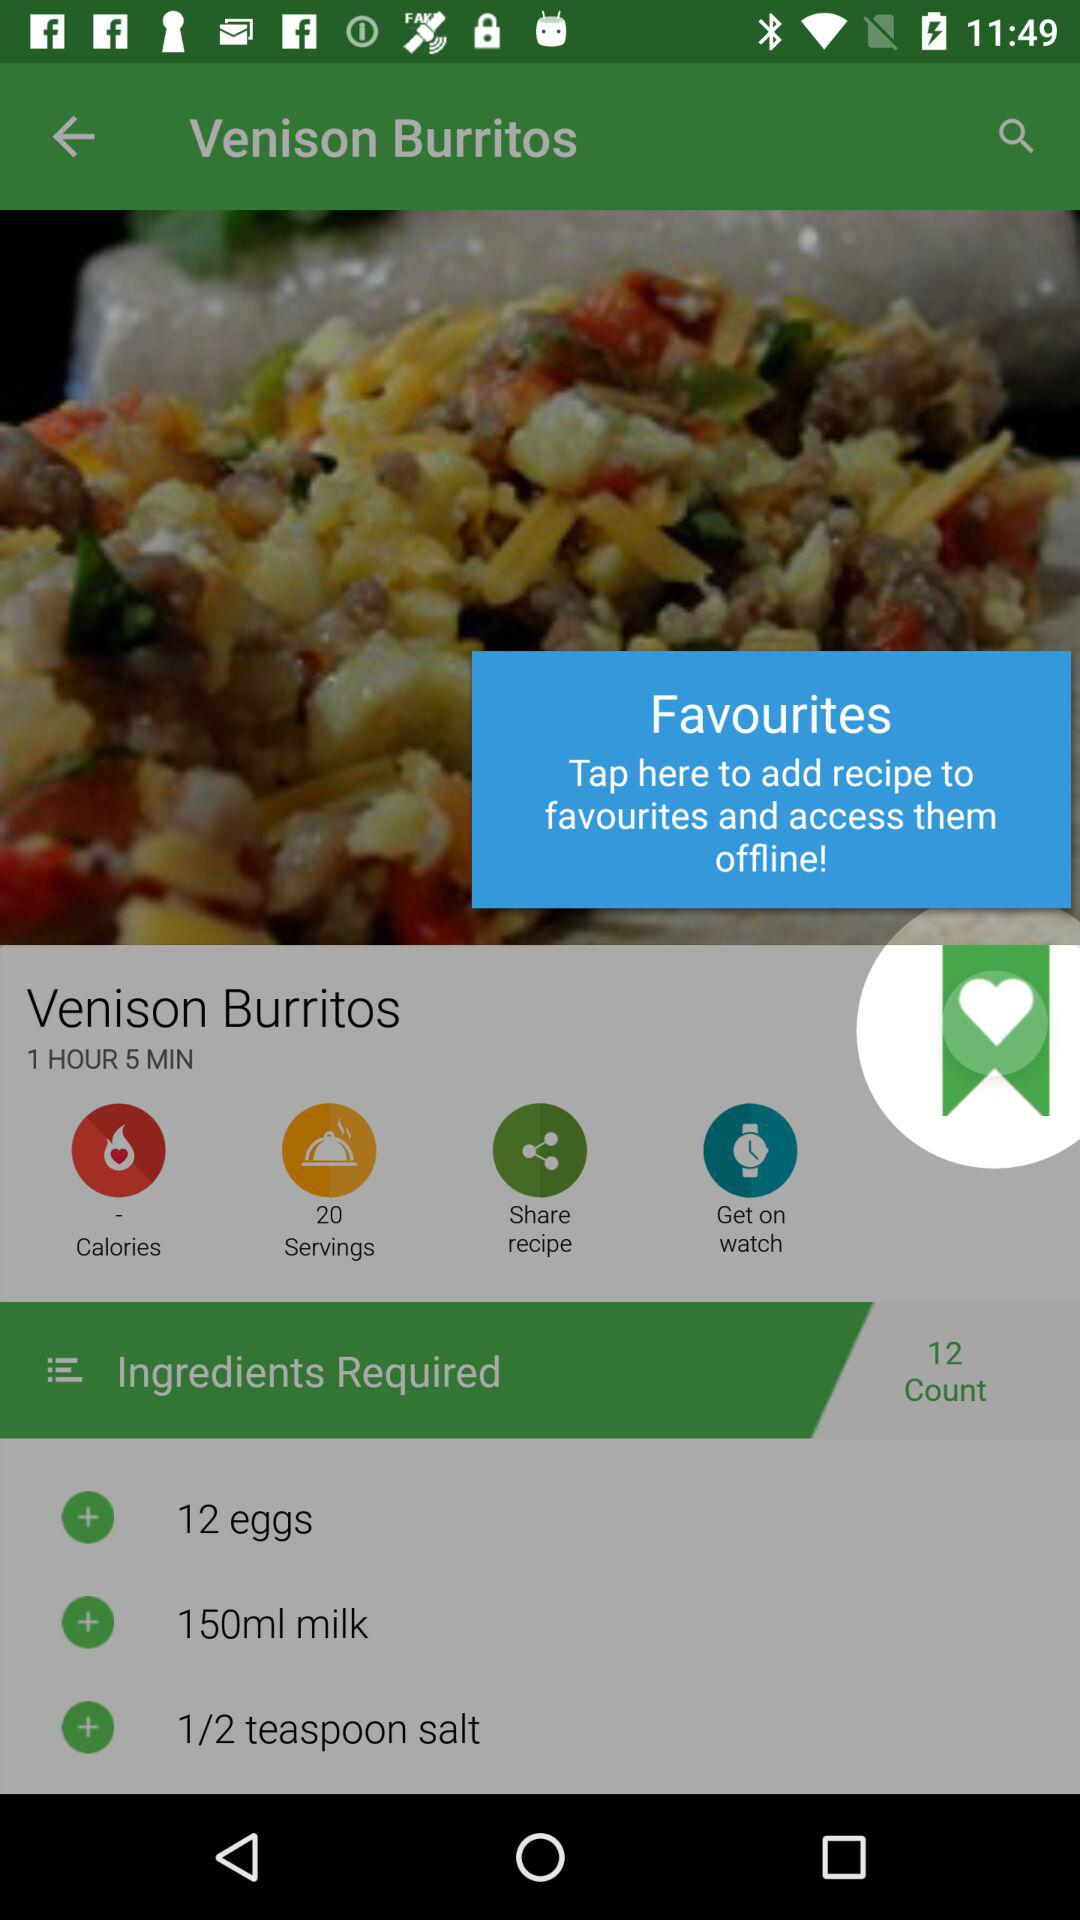What's the total number of required ingredients for the recipe? The total number of required ingredients is 12. 